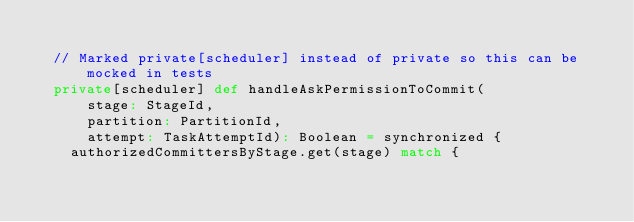<code> <loc_0><loc_0><loc_500><loc_500><_Scala_>
  // Marked private[scheduler] instead of private so this can be mocked in tests
  private[scheduler] def handleAskPermissionToCommit(
      stage: StageId,
      partition: PartitionId,
      attempt: TaskAttemptId): Boolean = synchronized {
    authorizedCommittersByStage.get(stage) match {</code> 